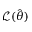<formula> <loc_0><loc_0><loc_500><loc_500>{ \mathcal { L } } ( { \hat { \theta } } )</formula> 